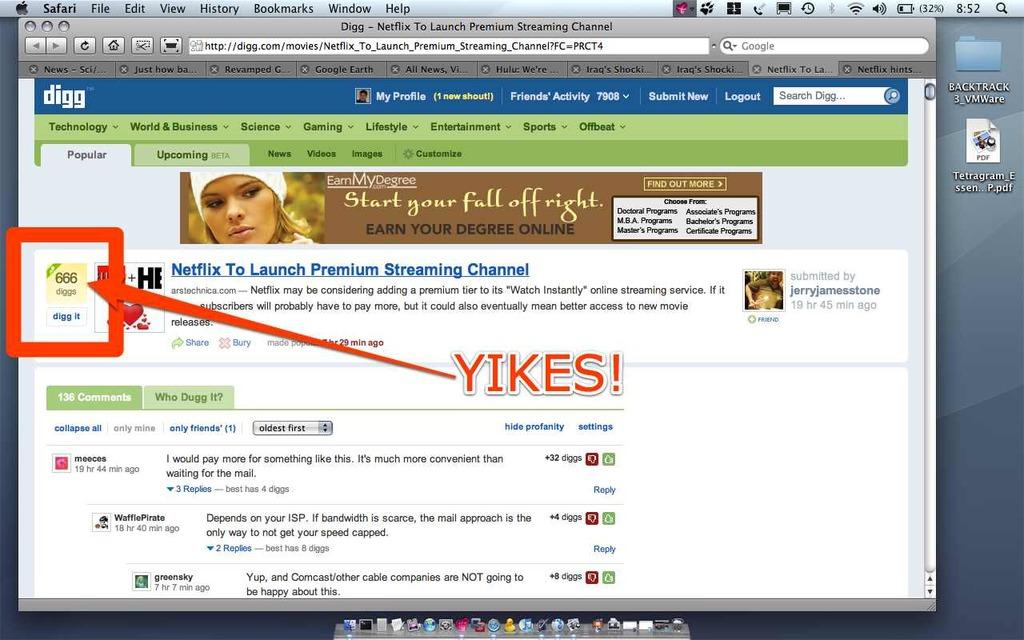What type of content is displayed in the image? The image is a web page. What can be found on the web page besides images or graphics? There is text on the web page. Are there any specific markers or labels on the web page? There are tags on the web page. Can you describe the visual representation of a person on the web page? There is a depiction of a person on the web page. What elements are present at the bottom of the web page? There are icons at the bottom of the web page. How long does it take for the person to walk from one end of the web page to the other? The person in the image is a depiction and not a real person, so they cannot walk. Additionally, the web page is a digital medium and not a physical space, so the concept of walking from one end to the other does not apply. 